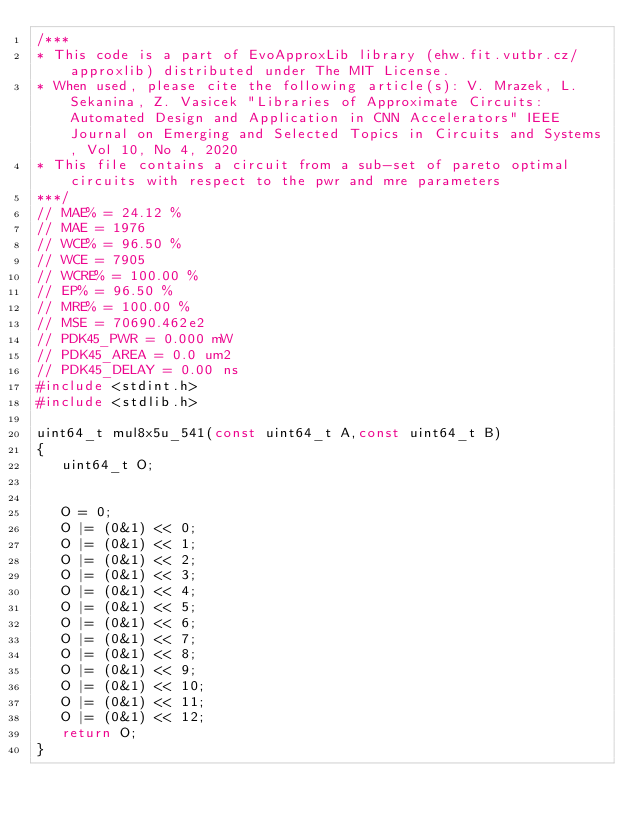<code> <loc_0><loc_0><loc_500><loc_500><_C_>/***
* This code is a part of EvoApproxLib library (ehw.fit.vutbr.cz/approxlib) distributed under The MIT License.
* When used, please cite the following article(s): V. Mrazek, L. Sekanina, Z. Vasicek "Libraries of Approximate Circuits: Automated Design and Application in CNN Accelerators" IEEE Journal on Emerging and Selected Topics in Circuits and Systems, Vol 10, No 4, 2020 
* This file contains a circuit from a sub-set of pareto optimal circuits with respect to the pwr and mre parameters
***/
// MAE% = 24.12 %
// MAE = 1976 
// WCE% = 96.50 %
// WCE = 7905 
// WCRE% = 100.00 %
// EP% = 96.50 %
// MRE% = 100.00 %
// MSE = 70690.462e2 
// PDK45_PWR = 0.000 mW
// PDK45_AREA = 0.0 um2
// PDK45_DELAY = 0.00 ns
#include <stdint.h>
#include <stdlib.h>

uint64_t mul8x5u_541(const uint64_t A,const uint64_t B)
{
   uint64_t O;


   O = 0;
   O |= (0&1) << 0;
   O |= (0&1) << 1;
   O |= (0&1) << 2;
   O |= (0&1) << 3;
   O |= (0&1) << 4;
   O |= (0&1) << 5;
   O |= (0&1) << 6;
   O |= (0&1) << 7;
   O |= (0&1) << 8;
   O |= (0&1) << 9;
   O |= (0&1) << 10;
   O |= (0&1) << 11;
   O |= (0&1) << 12;
   return O;
}
</code> 